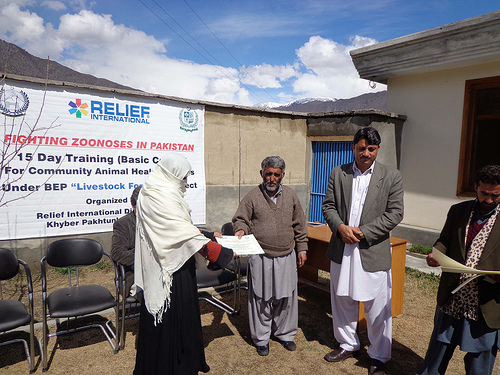<image>
Is the man on the chair? No. The man is not positioned on the chair. They may be near each other, but the man is not supported by or resting on top of the chair. 